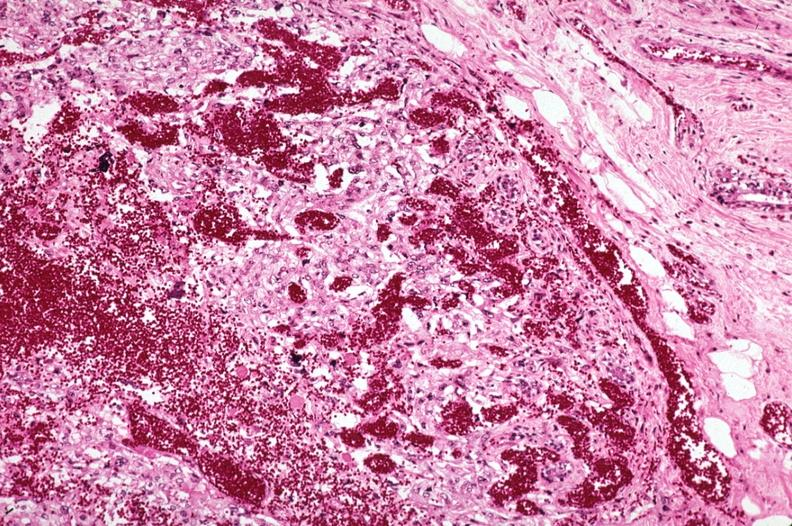where is this area in the body?
Answer the question using a single word or phrase. Breast 